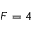Convert formula to latex. <formula><loc_0><loc_0><loc_500><loc_500>F = 4</formula> 